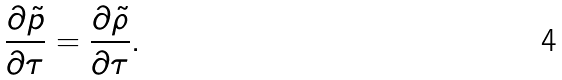<formula> <loc_0><loc_0><loc_500><loc_500>\frac { \partial \tilde { p } } { \partial \tau } = \frac { \partial \tilde { \rho } } { \partial \tau } .</formula> 